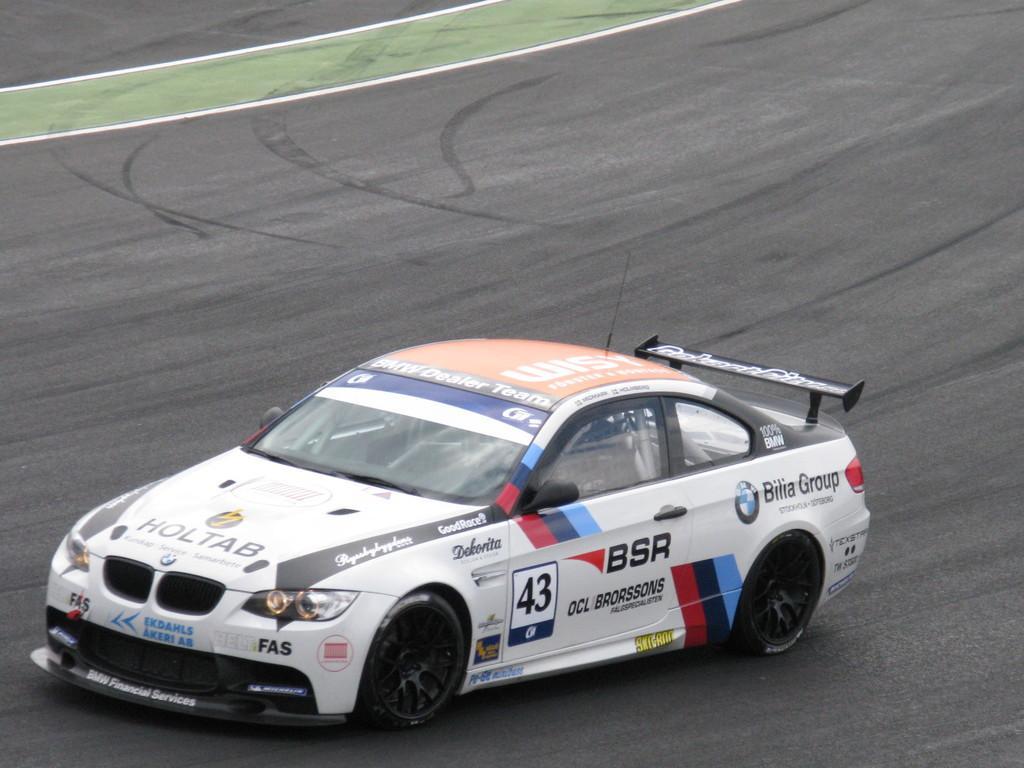Can you describe this image briefly? In this picture, there is a car on the road. It is in white in color. On the car, there is some text. 